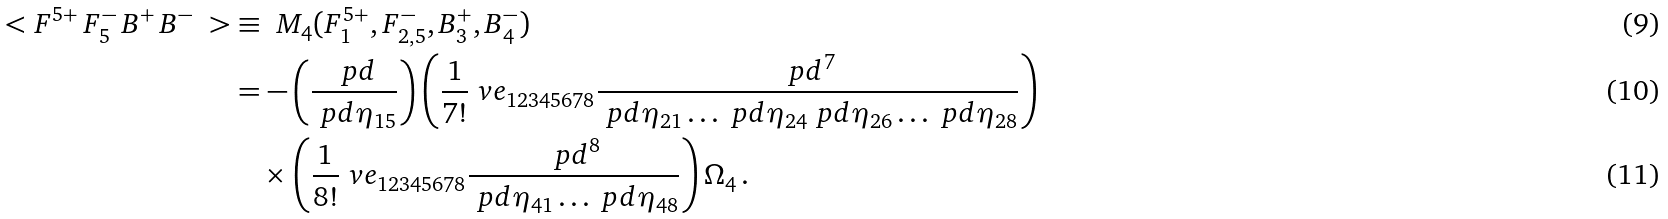Convert formula to latex. <formula><loc_0><loc_0><loc_500><loc_500>\ < F ^ { 5 + } \, F _ { 5 } ^ { - } \, B ^ { + } \, B ^ { - } \ > & \equiv \ M _ { 4 } ( F _ { 1 } ^ { 5 + } , F _ { 2 , 5 } ^ { - } , B _ { 3 } ^ { + } , B _ { 4 } ^ { - } ) \\ & = - \left ( \frac { \ p d } { \ p d \eta _ { 1 5 } } \right ) \left ( \frac { 1 } { 7 ! } \ v e _ { 1 2 3 4 5 6 7 8 } \frac { \ p d ^ { 7 } } { \ p d \eta _ { 2 1 } \dots \ p d \eta _ { 2 4 } \ p d \eta _ { 2 6 } \dots \ p d \eta _ { 2 8 } } \right ) \\ & \quad \times \left ( \frac { 1 } { 8 ! } \ v e _ { 1 2 3 4 5 6 7 8 } \frac { \ p d ^ { 8 } } { \ p d \eta _ { 4 1 } \dots \ p d \eta _ { 4 8 } } \right ) \Omega _ { 4 } \, .</formula> 